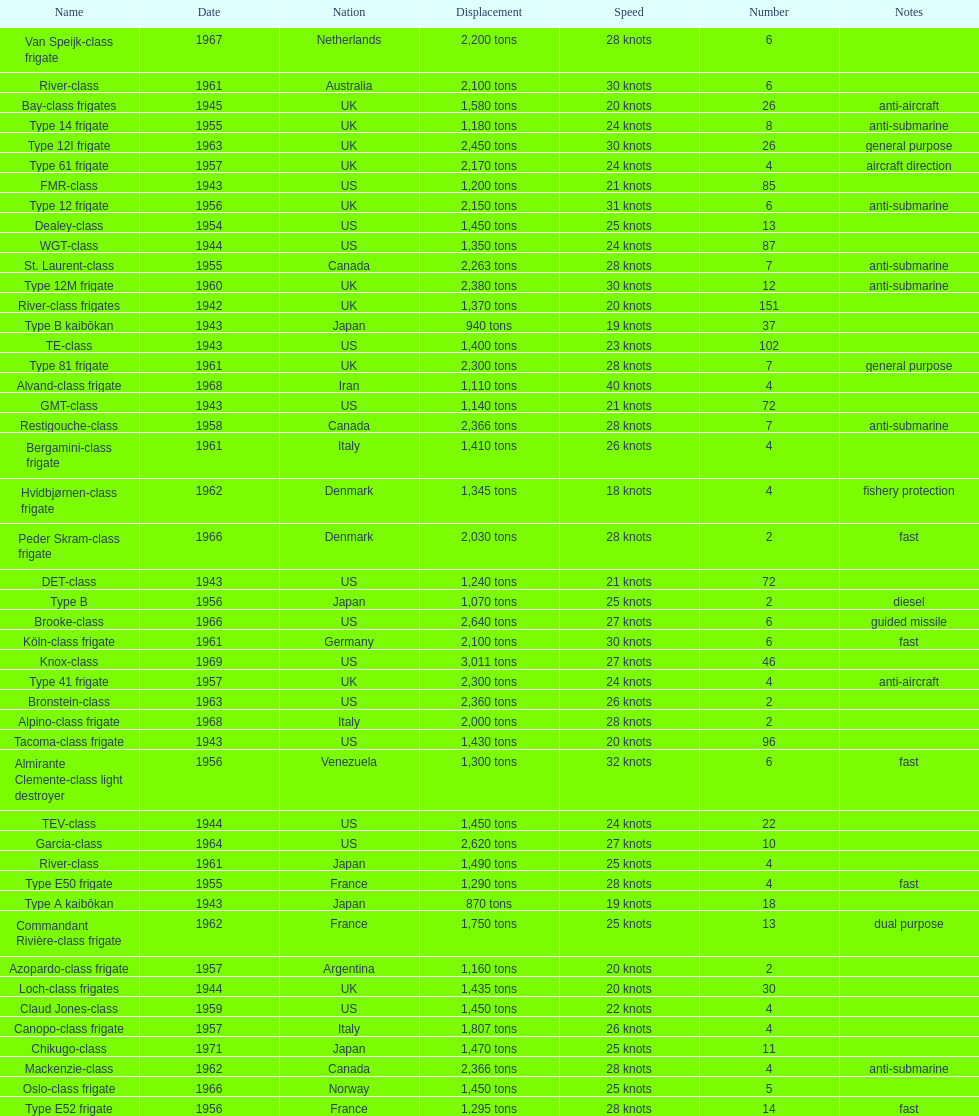Can you parse all the data within this table? {'header': ['Name', 'Date', 'Nation', 'Displacement', 'Speed', 'Number', 'Notes'], 'rows': [['Van Speijk-class frigate', '1967', 'Netherlands', '2,200 tons', '28 knots', '6', ''], ['River-class', '1961', 'Australia', '2,100 tons', '30 knots', '6', ''], ['Bay-class frigates', '1945', 'UK', '1,580 tons', '20 knots', '26', 'anti-aircraft'], ['Type 14 frigate', '1955', 'UK', '1,180 tons', '24 knots', '8', 'anti-submarine'], ['Type 12I frigate', '1963', 'UK', '2,450 tons', '30 knots', '26', 'general purpose'], ['Type 61 frigate', '1957', 'UK', '2,170 tons', '24 knots', '4', 'aircraft direction'], ['FMR-class', '1943', 'US', '1,200 tons', '21 knots', '85', ''], ['Type 12 frigate', '1956', 'UK', '2,150 tons', '31 knots', '6', 'anti-submarine'], ['Dealey-class', '1954', 'US', '1,450 tons', '25 knots', '13', ''], ['WGT-class', '1944', 'US', '1,350 tons', '24 knots', '87', ''], ['St. Laurent-class', '1955', 'Canada', '2,263 tons', '28 knots', '7', 'anti-submarine'], ['Type 12M frigate', '1960', 'UK', '2,380 tons', '30 knots', '12', 'anti-submarine'], ['River-class frigates', '1942', 'UK', '1,370 tons', '20 knots', '151', ''], ['Type B kaibōkan', '1943', 'Japan', '940 tons', '19 knots', '37', ''], ['TE-class', '1943', 'US', '1,400 tons', '23 knots', '102', ''], ['Type 81 frigate', '1961', 'UK', '2,300 tons', '28 knots', '7', 'general purpose'], ['Alvand-class frigate', '1968', 'Iran', '1,110 tons', '40 knots', '4', ''], ['GMT-class', '1943', 'US', '1,140 tons', '21 knots', '72', ''], ['Restigouche-class', '1958', 'Canada', '2,366 tons', '28 knots', '7', 'anti-submarine'], ['Bergamini-class frigate', '1961', 'Italy', '1,410 tons', '26 knots', '4', ''], ['Hvidbjørnen-class frigate', '1962', 'Denmark', '1,345 tons', '18 knots', '4', 'fishery protection'], ['Peder Skram-class frigate', '1966', 'Denmark', '2,030 tons', '28 knots', '2', 'fast'], ['DET-class', '1943', 'US', '1,240 tons', '21 knots', '72', ''], ['Type B', '1956', 'Japan', '1,070 tons', '25 knots', '2', 'diesel'], ['Brooke-class', '1966', 'US', '2,640 tons', '27 knots', '6', 'guided missile'], ['Köln-class frigate', '1961', 'Germany', '2,100 tons', '30 knots', '6', 'fast'], ['Knox-class', '1969', 'US', '3,011 tons', '27 knots', '46', ''], ['Type 41 frigate', '1957', 'UK', '2,300 tons', '24 knots', '4', 'anti-aircraft'], ['Bronstein-class', '1963', 'US', '2,360 tons', '26 knots', '2', ''], ['Alpino-class frigate', '1968', 'Italy', '2,000 tons', '28 knots', '2', ''], ['Tacoma-class frigate', '1943', 'US', '1,430 tons', '20 knots', '96', ''], ['Almirante Clemente-class light destroyer', '1956', 'Venezuela', '1,300 tons', '32 knots', '6', 'fast'], ['TEV-class', '1944', 'US', '1,450 tons', '24 knots', '22', ''], ['Garcia-class', '1964', 'US', '2,620 tons', '27 knots', '10', ''], ['River-class', '1961', 'Japan', '1,490 tons', '25 knots', '4', ''], ['Type E50 frigate', '1955', 'France', '1,290 tons', '28 knots', '4', 'fast'], ['Type A kaibōkan', '1943', 'Japan', '870 tons', '19 knots', '18', ''], ['Commandant Rivière-class frigate', '1962', 'France', '1,750 tons', '25 knots', '13', 'dual purpose'], ['Azopardo-class frigate', '1957', 'Argentina', '1,160 tons', '20 knots', '2', ''], ['Loch-class frigates', '1944', 'UK', '1,435 tons', '20 knots', '30', ''], ['Claud Jones-class', '1959', 'US', '1,450 tons', '22 knots', '4', ''], ['Canopo-class frigate', '1957', 'Italy', '1,807 tons', '26 knots', '4', ''], ['Chikugo-class', '1971', 'Japan', '1,470 tons', '25 knots', '11', ''], ['Mackenzie-class', '1962', 'Canada', '2,366 tons', '28 knots', '4', 'anti-submarine'], ['Oslo-class frigate', '1966', 'Norway', '1,450 tons', '25 knots', '5', ''], ['Type E52 frigate', '1956', 'France', '1,295 tons', '28 knots', '14', 'fast']]} What is the difference in speed for the gmt-class and the te-class? 2 knots. 